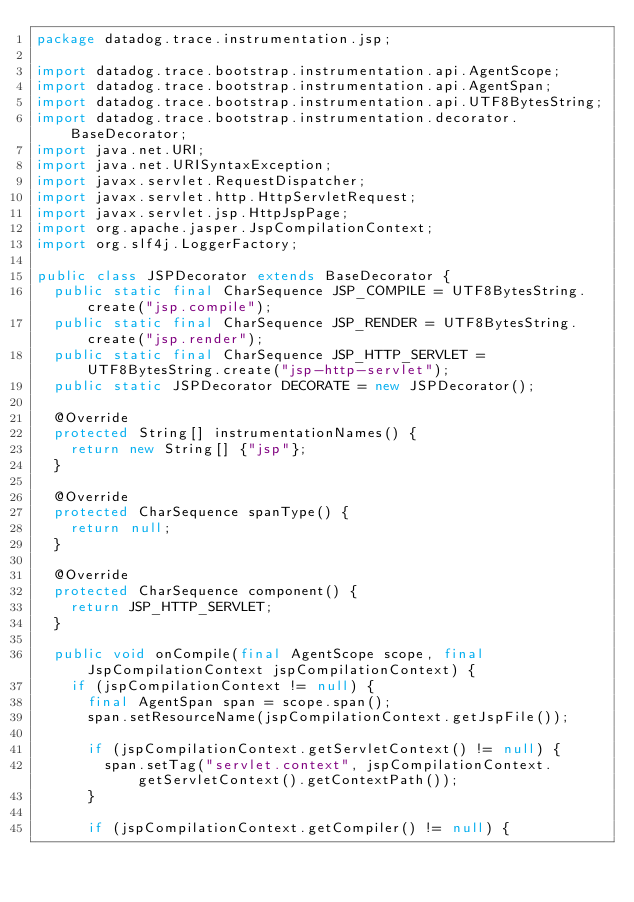Convert code to text. <code><loc_0><loc_0><loc_500><loc_500><_Java_>package datadog.trace.instrumentation.jsp;

import datadog.trace.bootstrap.instrumentation.api.AgentScope;
import datadog.trace.bootstrap.instrumentation.api.AgentSpan;
import datadog.trace.bootstrap.instrumentation.api.UTF8BytesString;
import datadog.trace.bootstrap.instrumentation.decorator.BaseDecorator;
import java.net.URI;
import java.net.URISyntaxException;
import javax.servlet.RequestDispatcher;
import javax.servlet.http.HttpServletRequest;
import javax.servlet.jsp.HttpJspPage;
import org.apache.jasper.JspCompilationContext;
import org.slf4j.LoggerFactory;

public class JSPDecorator extends BaseDecorator {
  public static final CharSequence JSP_COMPILE = UTF8BytesString.create("jsp.compile");
  public static final CharSequence JSP_RENDER = UTF8BytesString.create("jsp.render");
  public static final CharSequence JSP_HTTP_SERVLET = UTF8BytesString.create("jsp-http-servlet");
  public static JSPDecorator DECORATE = new JSPDecorator();

  @Override
  protected String[] instrumentationNames() {
    return new String[] {"jsp"};
  }

  @Override
  protected CharSequence spanType() {
    return null;
  }

  @Override
  protected CharSequence component() {
    return JSP_HTTP_SERVLET;
  }

  public void onCompile(final AgentScope scope, final JspCompilationContext jspCompilationContext) {
    if (jspCompilationContext != null) {
      final AgentSpan span = scope.span();
      span.setResourceName(jspCompilationContext.getJspFile());

      if (jspCompilationContext.getServletContext() != null) {
        span.setTag("servlet.context", jspCompilationContext.getServletContext().getContextPath());
      }

      if (jspCompilationContext.getCompiler() != null) {</code> 